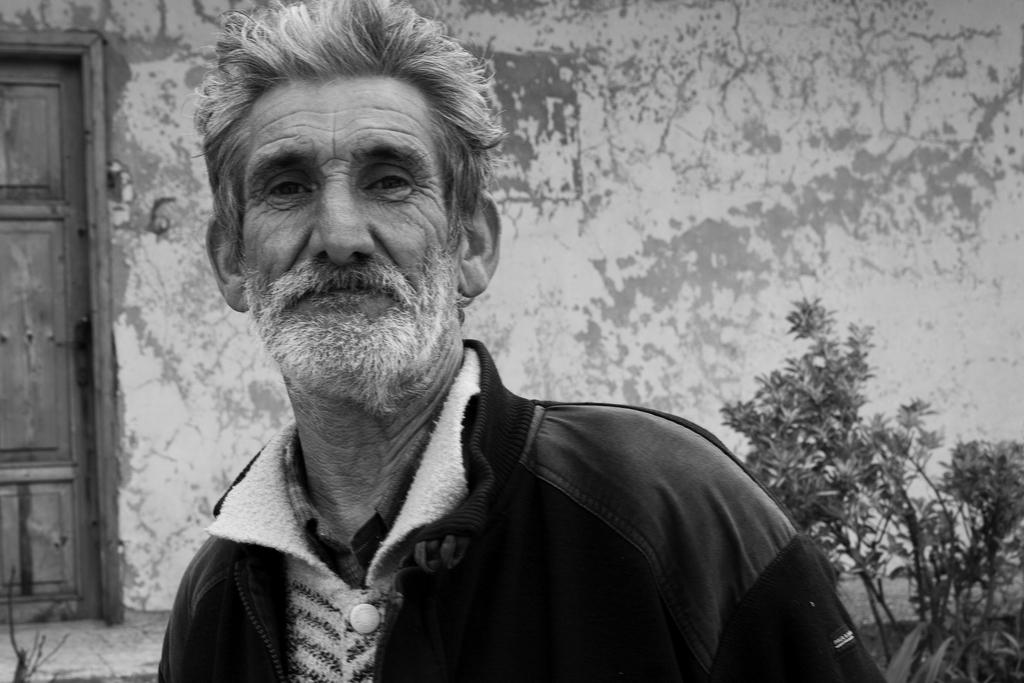What is the color scheme of the image? The image is black and white. Who or what is in the foreground of the image? There is a person in the foreground of the image. What is the person wearing? The person is wearing a jacket. What type of natural elements can be seen in the image? There are plants visible in the image. What type of man-made structure is present in the image? There is a wall and a door in the image. What type of relation does the person have with the rake in the image? There is no rake present in the image, so it is not possible to determine any relation between the person and a rake. 